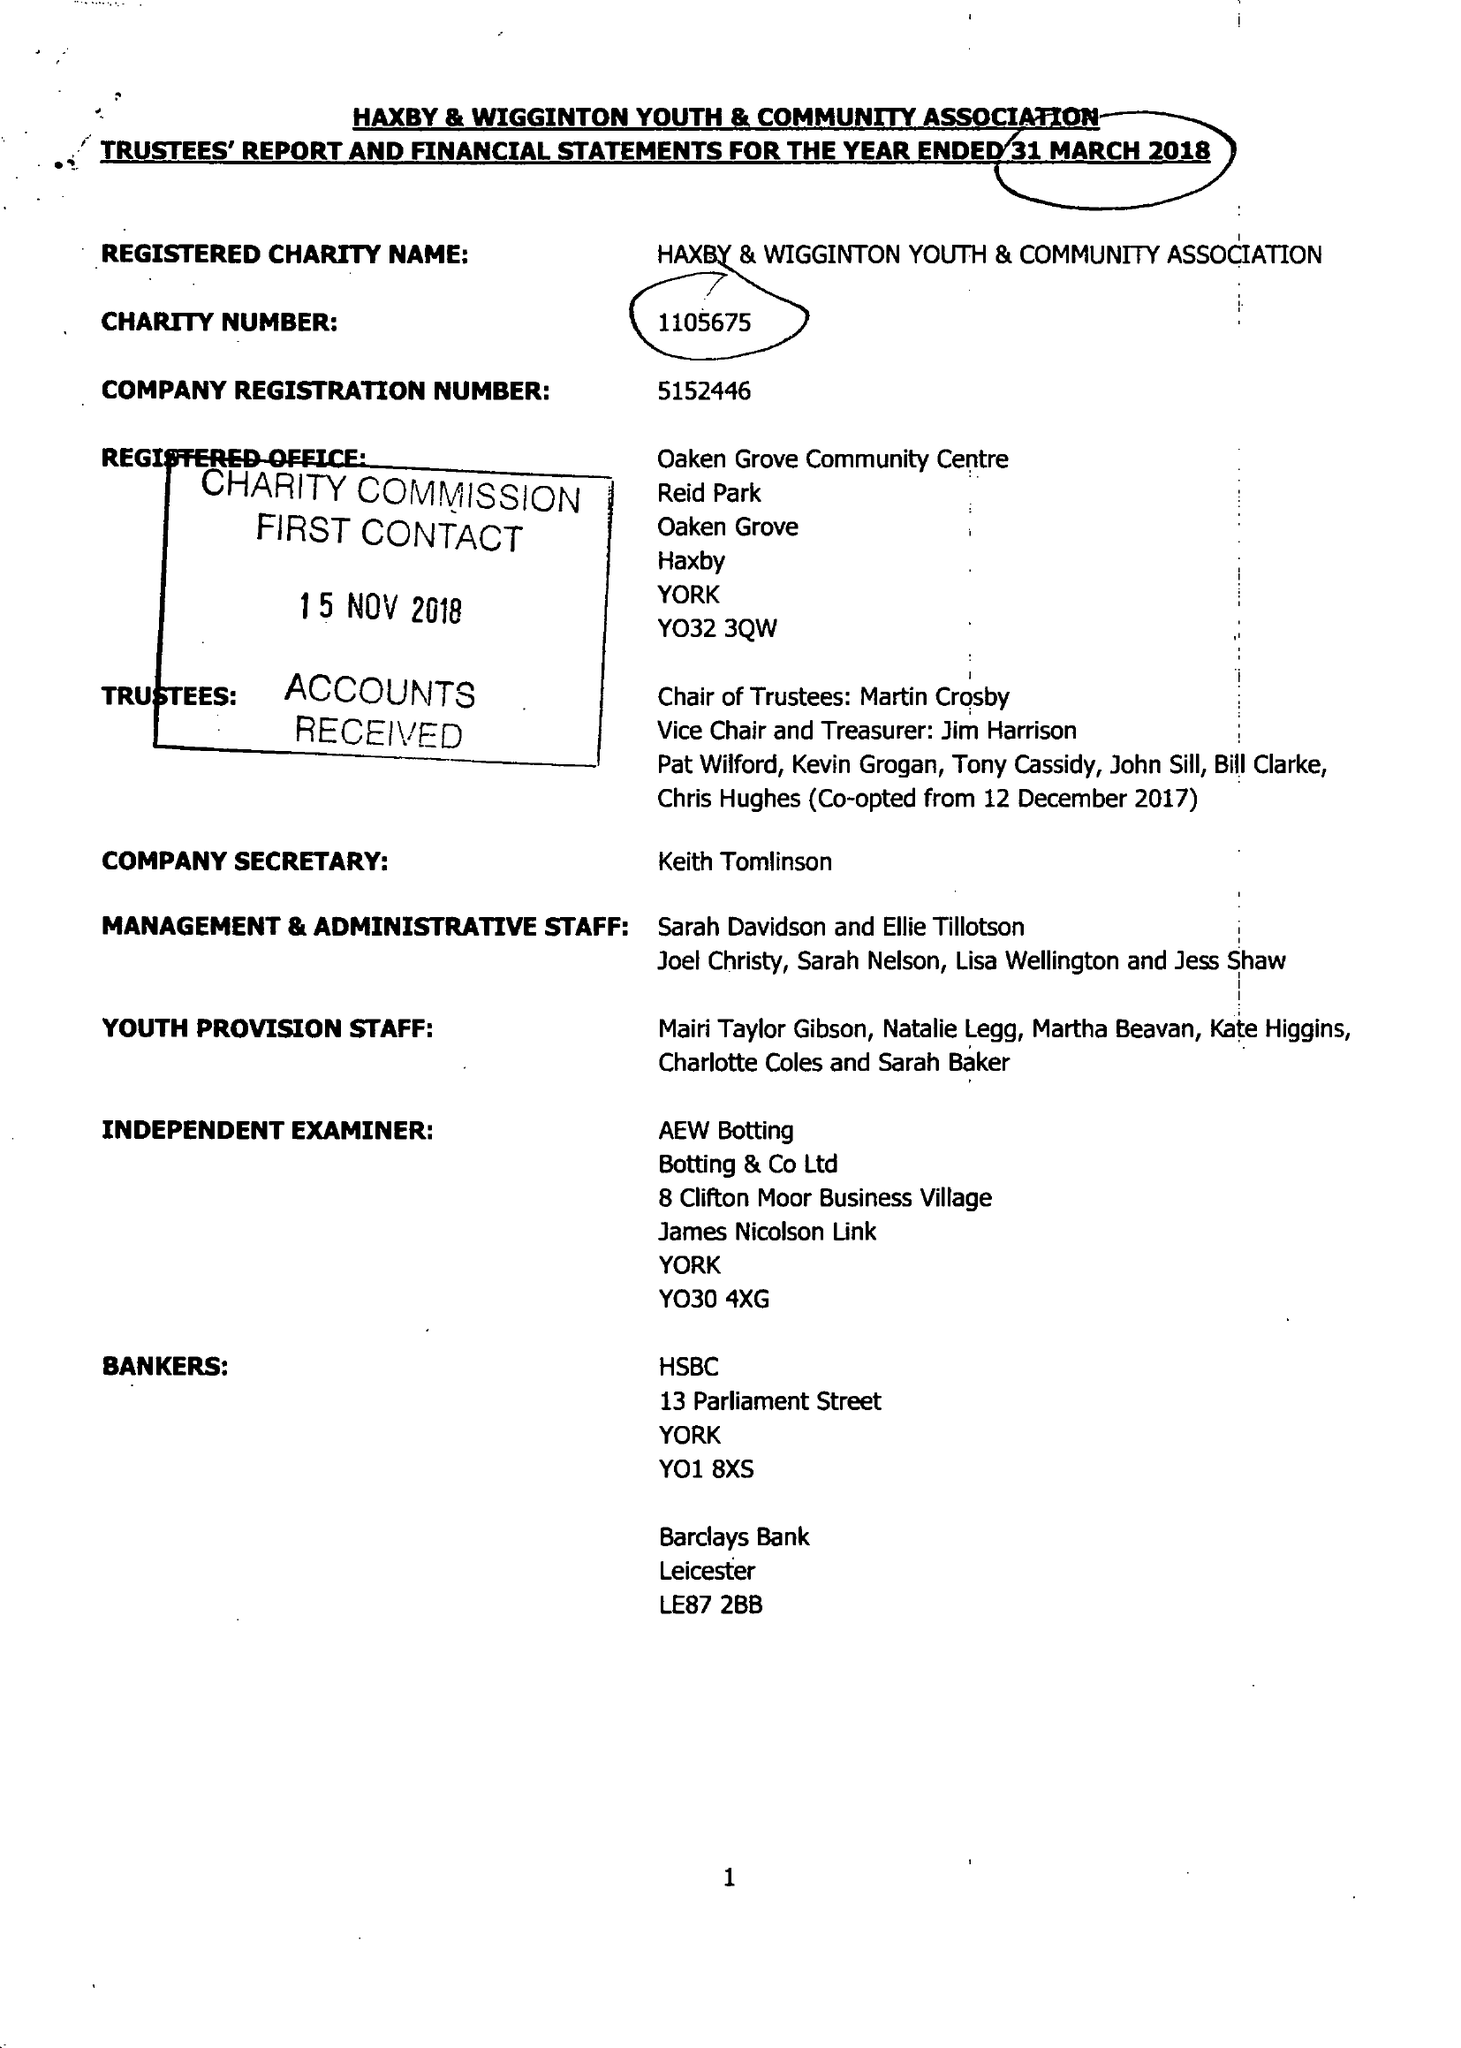What is the value for the address__street_line?
Answer the question using a single word or phrase. None 